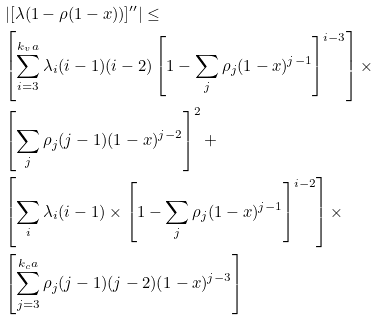<formula> <loc_0><loc_0><loc_500><loc_500>& { \left | [ \lambda ( 1 - \rho ( 1 - x ) ) ] ^ { \prime \prime } \right | \leq } \\ & { \left [ \sum _ { i = 3 } ^ { k _ { v } a } \lambda _ { i } ( i - 1 ) ( i - 2 ) \left [ 1 - \sum _ { j } \rho _ { j } ( 1 - x ) ^ { j - 1 } \right ] ^ { i - 3 } \right ] \times } \\ & { \left [ \sum _ { j } \rho _ { j } ( j - 1 ) ( 1 - x ) ^ { j - 2 } \right ] ^ { 2 } + } \\ & { \left [ \sum _ { i } \lambda _ { i } ( i - 1 ) \times \left [ 1 - \sum _ { j } \rho _ { j } ( 1 - x ) ^ { j - 1 } \right ] ^ { i - 2 } \right ] \times } \\ & { \left [ \sum _ { j = 3 } ^ { k _ { c } a } \rho _ { j } ( j - 1 ) ( j - 2 ) ( 1 - x ) ^ { j - 3 } \right ] }</formula> 